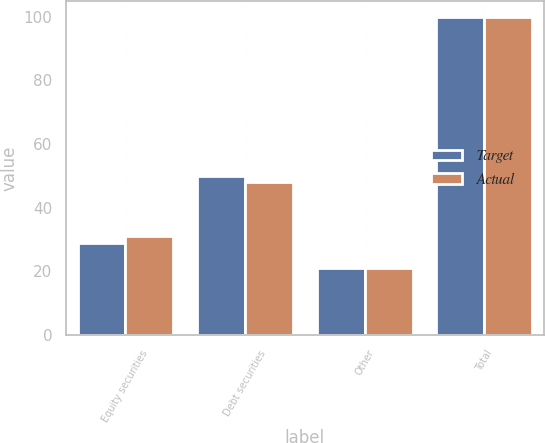Convert chart to OTSL. <chart><loc_0><loc_0><loc_500><loc_500><stacked_bar_chart><ecel><fcel>Equity securities<fcel>Debt securities<fcel>Other<fcel>Total<nl><fcel>Target<fcel>29<fcel>50<fcel>21<fcel>100<nl><fcel>Actual<fcel>31<fcel>48<fcel>21<fcel>100<nl></chart> 